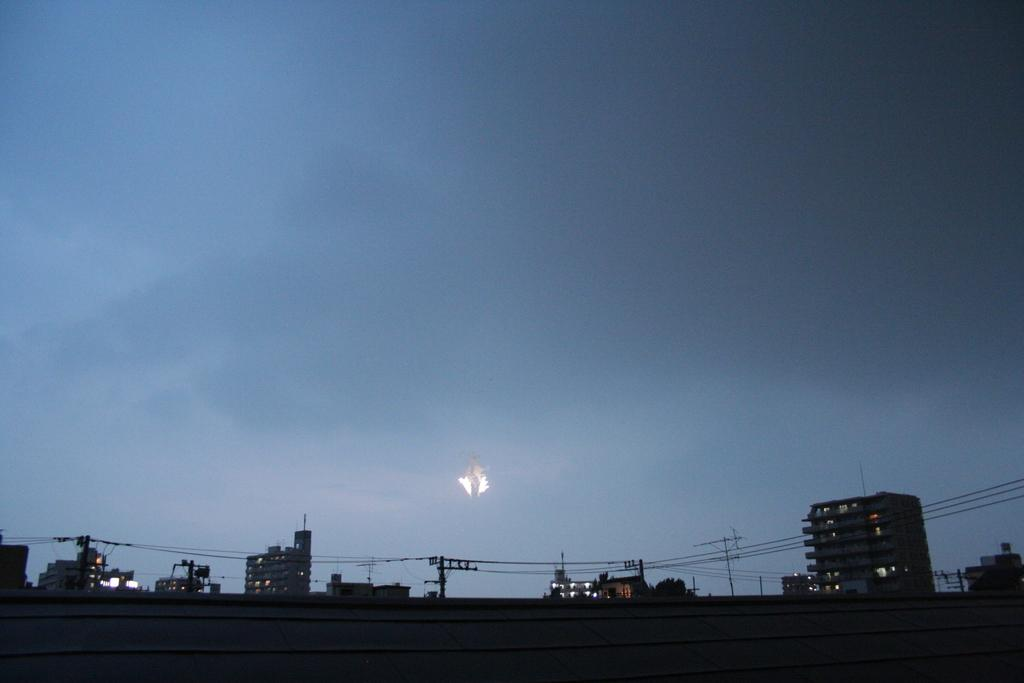What type of structures can be seen in the image? There are buildings in the image. What else is present in the image besides the buildings? There are poles and cables in the image. What can be seen in the background of the image? The sky is visible in the background of the image. What is at the bottom of the image? There is a wall at the bottom of the image. Whose birthday is being celebrated in the image? There is no indication of a birthday celebration in the image. Can you tell me how many sons are present in the image? There are no people, let alone sons, present in the image. 